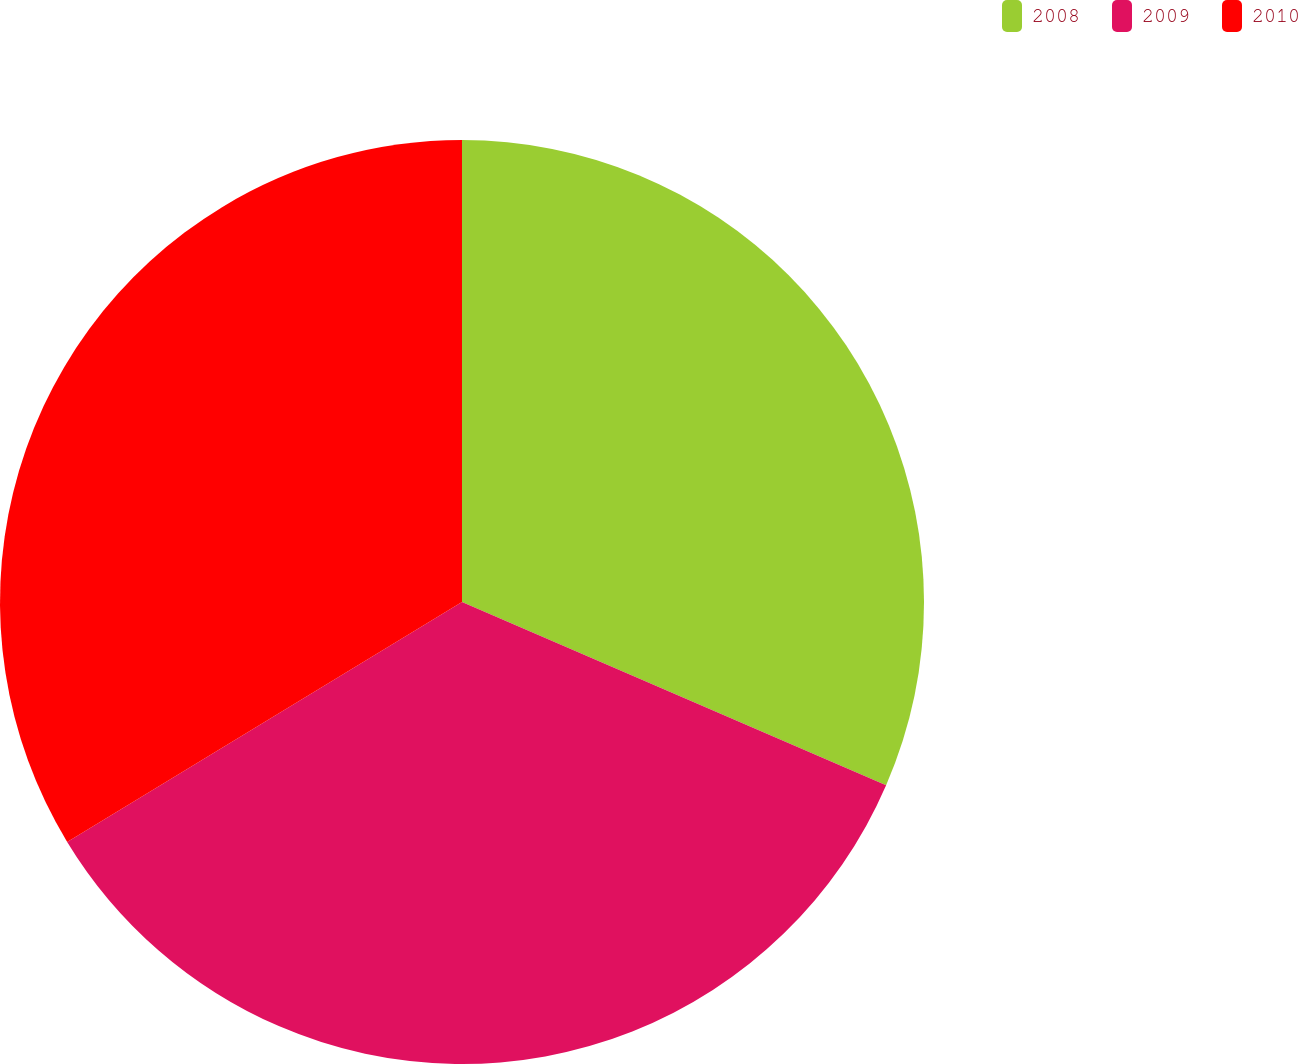Convert chart to OTSL. <chart><loc_0><loc_0><loc_500><loc_500><pie_chart><fcel>2008<fcel>2009<fcel>2010<nl><fcel>31.49%<fcel>34.82%<fcel>33.69%<nl></chart> 